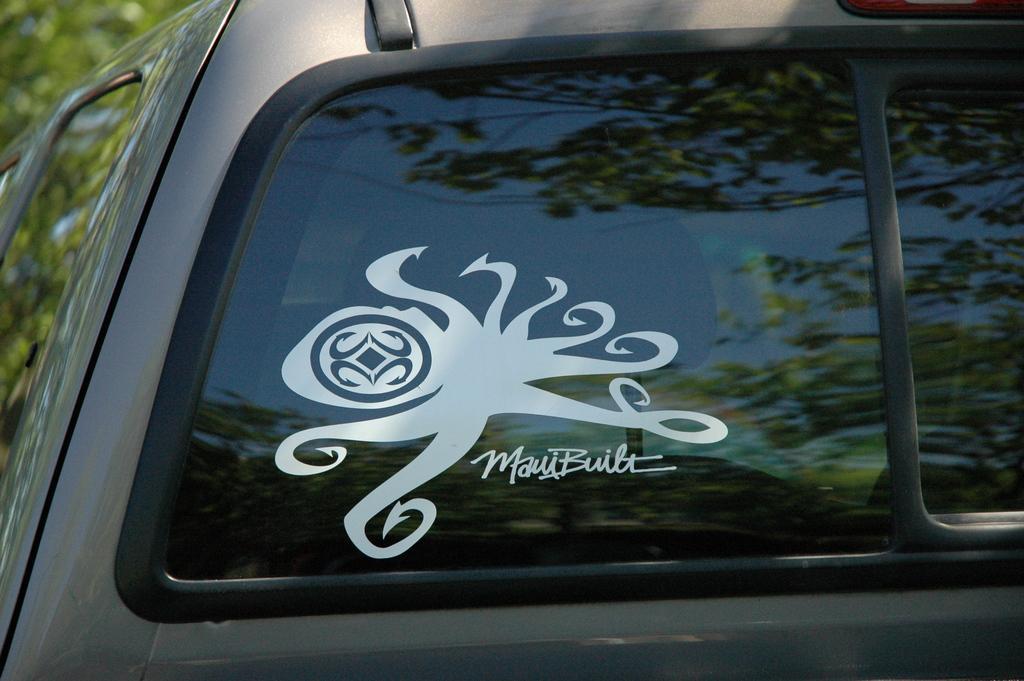Describe this image in one or two sentences. In this image I can see a grey color vehicle and a glass. I can see a white color sticker attached to the it. Back I can see few trees. 